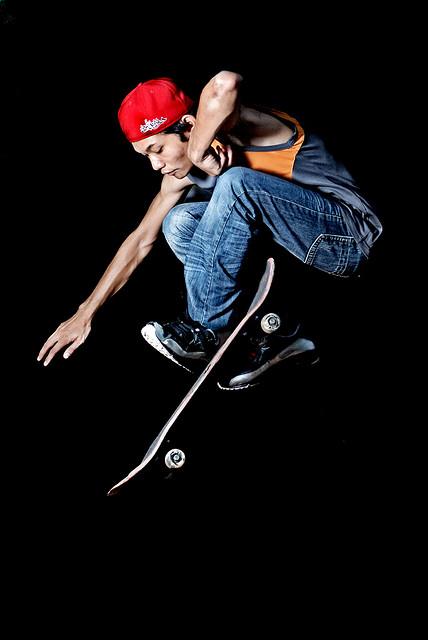What color is the skaters hat?
Give a very brief answer. Red. Is this a man or woman flying?
Concise answer only. Man. What is the gender of the skater?
Short answer required. Male. 